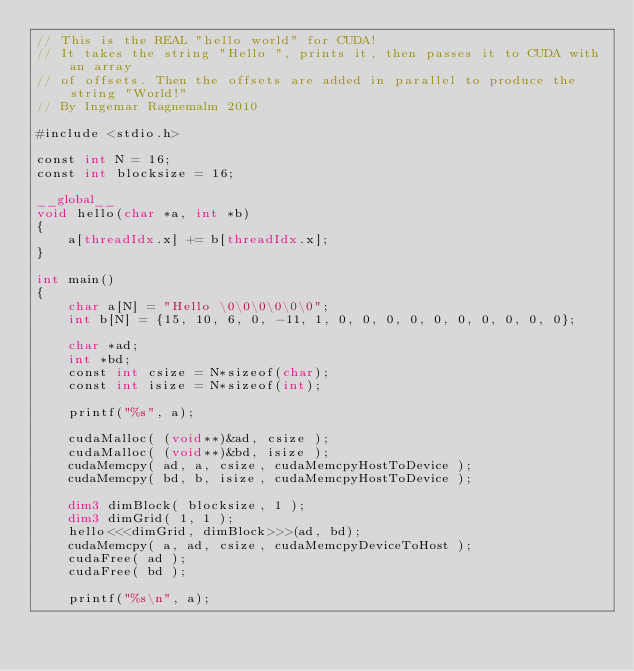Convert code to text. <code><loc_0><loc_0><loc_500><loc_500><_Cuda_>// This is the REAL "hello world" for CUDA!
// It takes the string "Hello ", prints it, then passes it to CUDA with an array
// of offsets. Then the offsets are added in parallel to produce the string "World!"
// By Ingemar Ragnemalm 2010
 
#include <stdio.h>
 
const int N = 16; 
const int blocksize = 16; 
 
__global__ 
void hello(char *a, int *b) 
{
    a[threadIdx.x] += b[threadIdx.x];
}
 
int main()
{
    char a[N] = "Hello \0\0\0\0\0\0";
    int b[N] = {15, 10, 6, 0, -11, 1, 0, 0, 0, 0, 0, 0, 0, 0, 0, 0};
 
    char *ad;
    int *bd;
    const int csize = N*sizeof(char);
    const int isize = N*sizeof(int);
 
    printf("%s", a);
 
    cudaMalloc( (void**)&ad, csize ); 
    cudaMalloc( (void**)&bd, isize ); 
    cudaMemcpy( ad, a, csize, cudaMemcpyHostToDevice ); 
    cudaMemcpy( bd, b, isize, cudaMemcpyHostToDevice ); 
    
    dim3 dimBlock( blocksize, 1 );
    dim3 dimGrid( 1, 1 );
    hello<<<dimGrid, dimBlock>>>(ad, bd);
    cudaMemcpy( a, ad, csize, cudaMemcpyDeviceToHost ); 
    cudaFree( ad );
    cudaFree( bd );
    
    printf("%s\n", a);</code> 